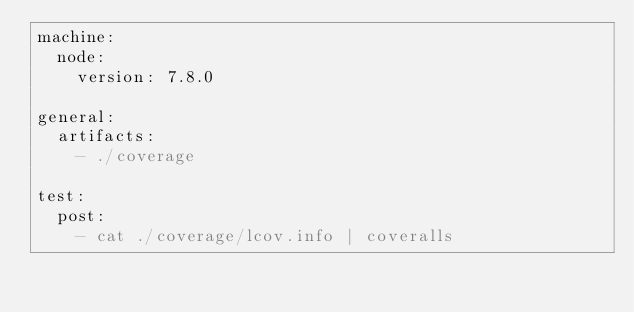Convert code to text. <code><loc_0><loc_0><loc_500><loc_500><_YAML_>machine:
  node:
    version: 7.8.0

general:
  artifacts:
    - ./coverage

test:
  post:
    - cat ./coverage/lcov.info | coveralls
</code> 